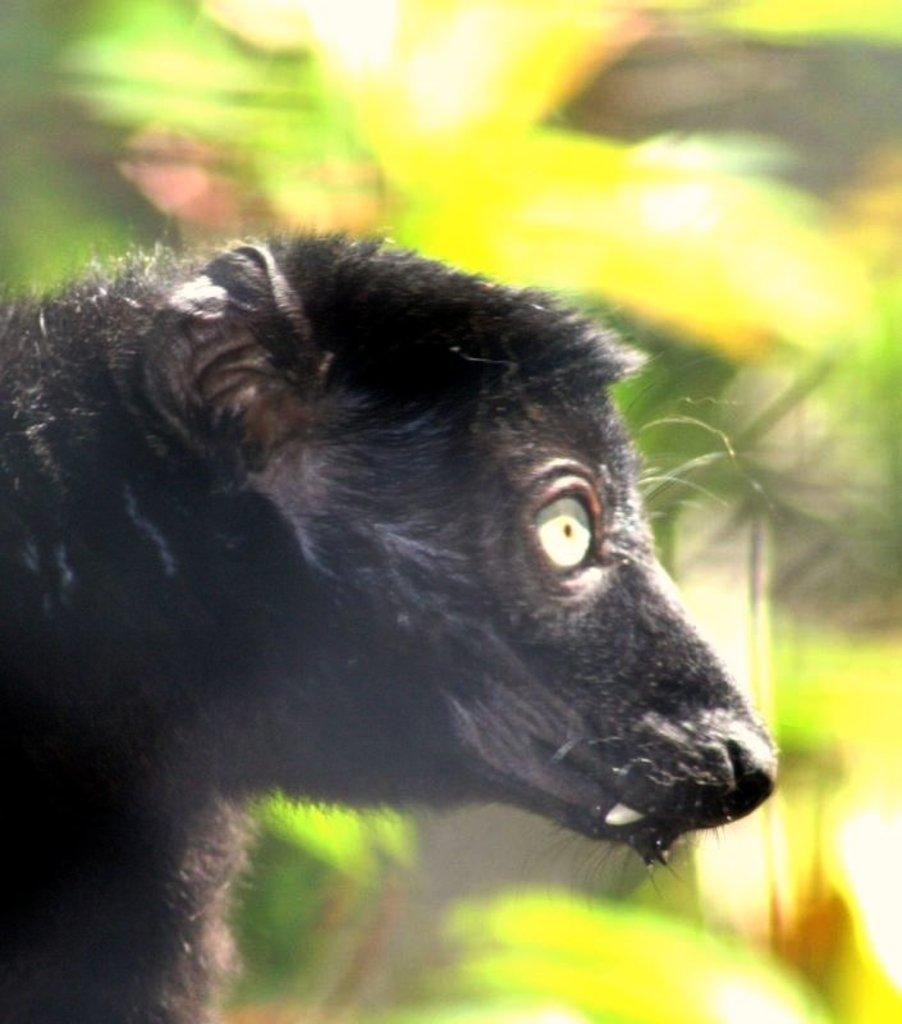What type of animal is present in the image? There is an animal in the image, but its specific type cannot be determined from the provided facts. What color is the animal in the image? The animal is black in color. How is the animal positioned in the image? The animal is blurred in the background. What type of basket is the animal carrying in the image? There is no basket present in the image; the animal is blurred in the background. 